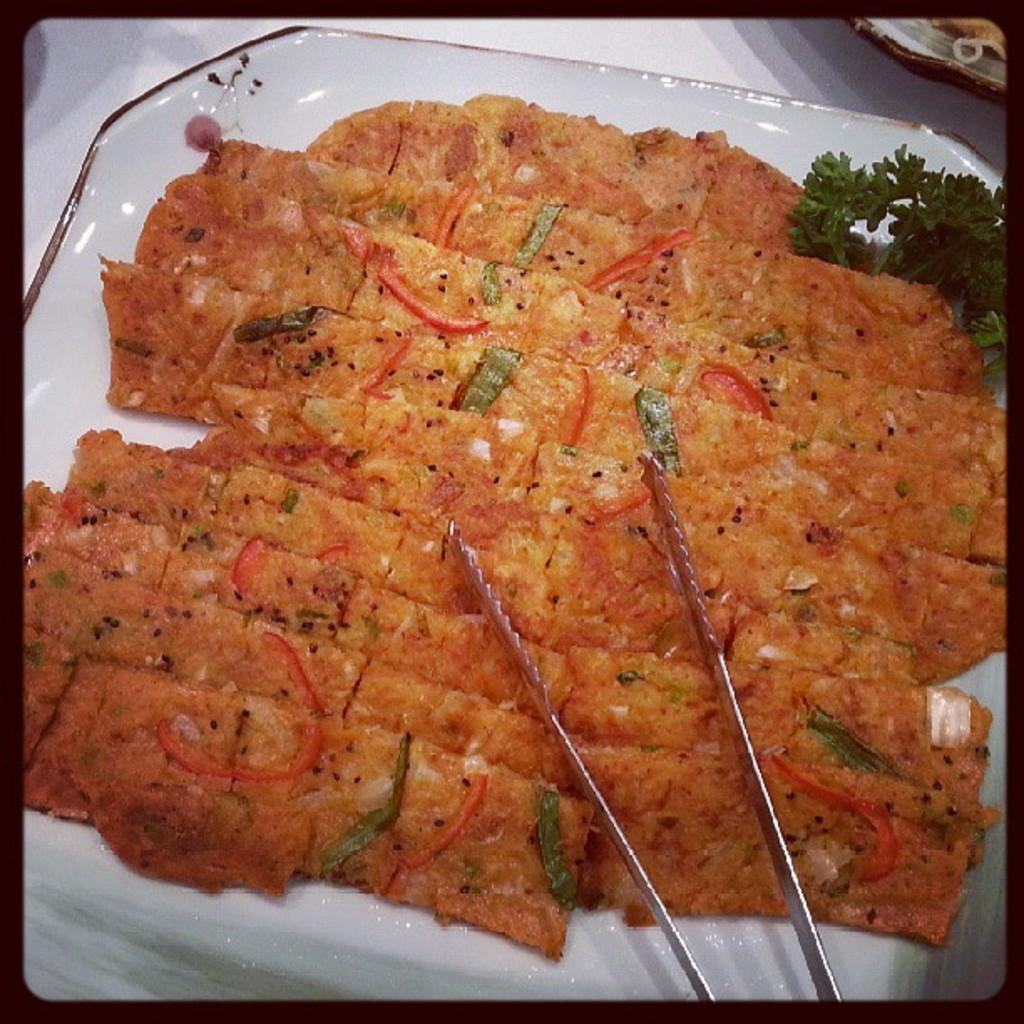What is on the plate in the image? There is a food item on a plate in the image. How is the food item being consumed in the image? There is a spoon used to pick the food item in the image. What type of leaves are present in the image? Coromandel leaves are present in the image. What type of wool is being used to solve arithmetic problems in the image? There is no wool or arithmetic problems present in the image. 